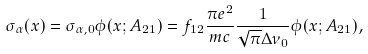Convert formula to latex. <formula><loc_0><loc_0><loc_500><loc_500>\sigma _ { \alpha } ( x ) = \sigma _ { \alpha , 0 } \phi ( x ; A _ { 2 1 } ) = f _ { 1 2 } \frac { \pi e ^ { 2 } } { m c } \frac { 1 } { \sqrt { \pi } \Delta \nu _ { 0 } } \phi ( x ; A _ { 2 1 } ) ,</formula> 